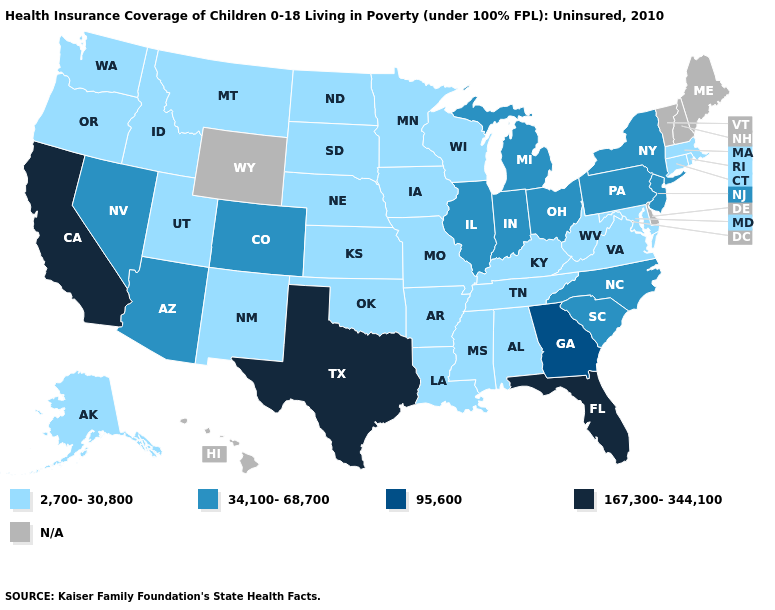Name the states that have a value in the range N/A?
Concise answer only. Delaware, Hawaii, Maine, New Hampshire, Vermont, Wyoming. Which states have the lowest value in the USA?
Short answer required. Alabama, Alaska, Arkansas, Connecticut, Idaho, Iowa, Kansas, Kentucky, Louisiana, Maryland, Massachusetts, Minnesota, Mississippi, Missouri, Montana, Nebraska, New Mexico, North Dakota, Oklahoma, Oregon, Rhode Island, South Dakota, Tennessee, Utah, Virginia, Washington, West Virginia, Wisconsin. Name the states that have a value in the range N/A?
Be succinct. Delaware, Hawaii, Maine, New Hampshire, Vermont, Wyoming. Name the states that have a value in the range 167,300-344,100?
Keep it brief. California, Florida, Texas. How many symbols are there in the legend?
Give a very brief answer. 5. Is the legend a continuous bar?
Quick response, please. No. What is the value of New Jersey?
Quick response, please. 34,100-68,700. Which states have the highest value in the USA?
Be succinct. California, Florida, Texas. What is the lowest value in states that border Nebraska?
Be succinct. 2,700-30,800. Name the states that have a value in the range N/A?
Quick response, please. Delaware, Hawaii, Maine, New Hampshire, Vermont, Wyoming. Among the states that border Connecticut , does New York have the highest value?
Quick response, please. Yes. Which states have the lowest value in the USA?
Quick response, please. Alabama, Alaska, Arkansas, Connecticut, Idaho, Iowa, Kansas, Kentucky, Louisiana, Maryland, Massachusetts, Minnesota, Mississippi, Missouri, Montana, Nebraska, New Mexico, North Dakota, Oklahoma, Oregon, Rhode Island, South Dakota, Tennessee, Utah, Virginia, Washington, West Virginia, Wisconsin. Among the states that border Illinois , which have the highest value?
Keep it brief. Indiana. Name the states that have a value in the range 95,600?
Concise answer only. Georgia. Name the states that have a value in the range 2,700-30,800?
Give a very brief answer. Alabama, Alaska, Arkansas, Connecticut, Idaho, Iowa, Kansas, Kentucky, Louisiana, Maryland, Massachusetts, Minnesota, Mississippi, Missouri, Montana, Nebraska, New Mexico, North Dakota, Oklahoma, Oregon, Rhode Island, South Dakota, Tennessee, Utah, Virginia, Washington, West Virginia, Wisconsin. 